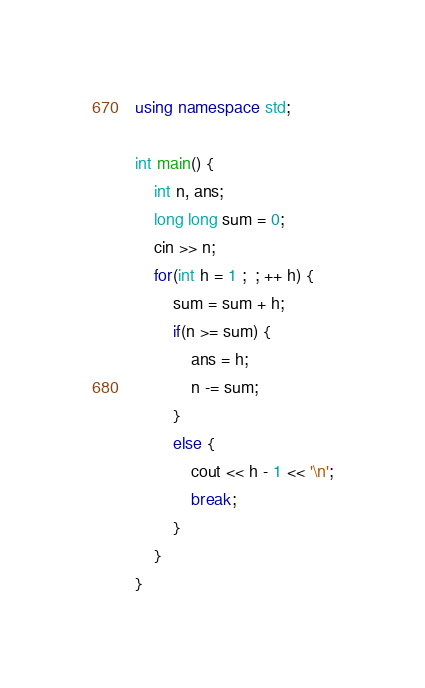Convert code to text. <code><loc_0><loc_0><loc_500><loc_500><_C++_>
using namespace std;

int main() {
	int n, ans;
	long long sum = 0;
	cin >> n;
	for(int h = 1 ;  ; ++ h) {
		sum = sum + h;	
		if(n >= sum) {
			ans = h;
			n -= sum;
		}
		else {
			cout << h - 1 << '\n';
			break;
		}
	}
}
</code> 